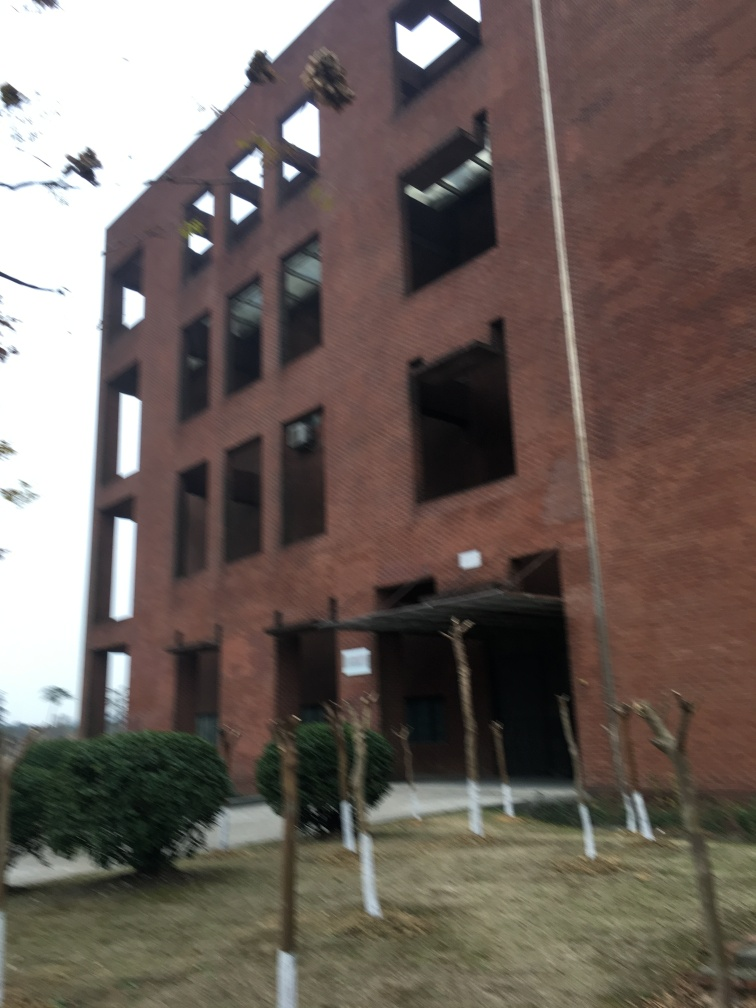What does the landscaping tell us about the location or care given to this setting? The landscaping around the building features young trees supported by stakes, and shrubs that appear to be well-maintained, suggesting that while the building itself may not be in use, care is still being given to the surrounding environment. This could hint at future development plans or a respect for maintaining a presentable exterior. 